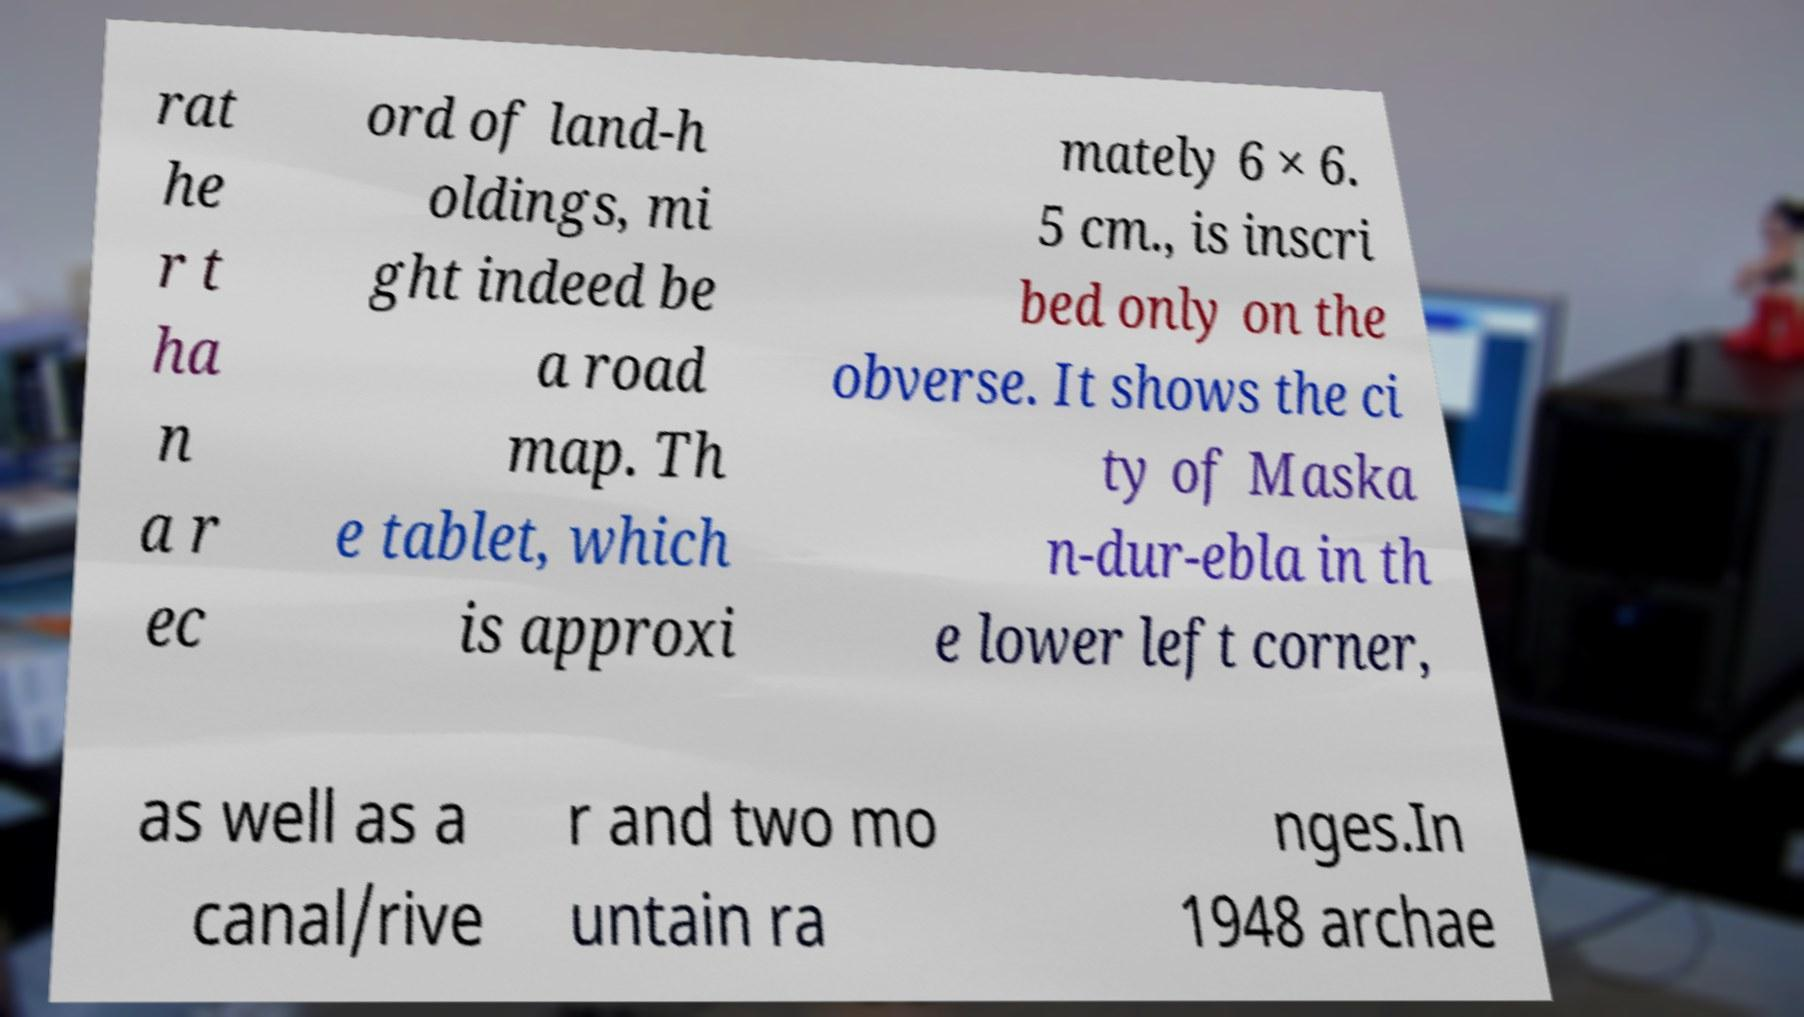For documentation purposes, I need the text within this image transcribed. Could you provide that? rat he r t ha n a r ec ord of land-h oldings, mi ght indeed be a road map. Th e tablet, which is approxi mately 6 × 6. 5 cm., is inscri bed only on the obverse. It shows the ci ty of Maska n-dur-ebla in th e lower left corner, as well as a canal/rive r and two mo untain ra nges.In 1948 archae 